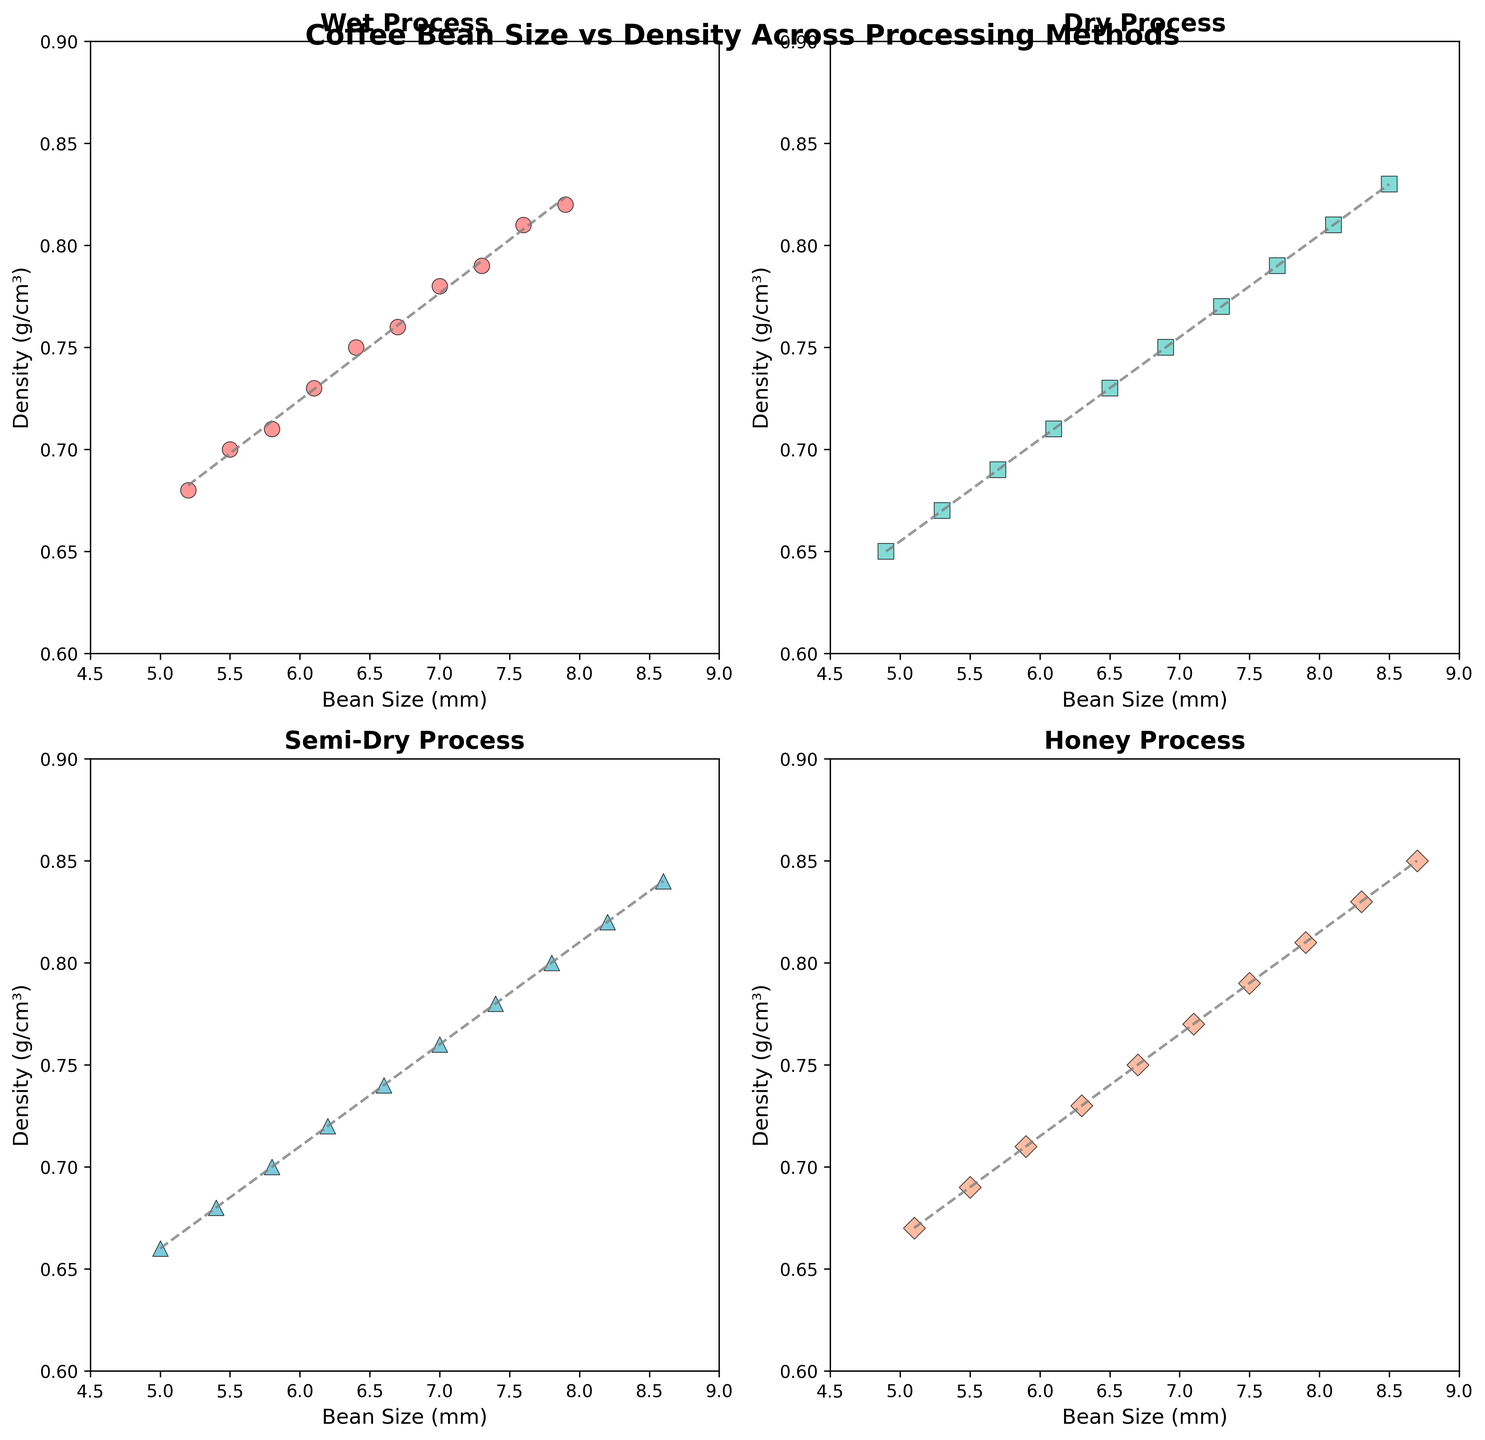What's the average bean size for the Dry Process? To find the average bean size for the Dry Process, add all the bean sizes for the Dry Process and divide by the number of data points: (4.9 + 5.3 + 5.7 + 6.1 + 6.5 + 6.9 + 7.3 + 7.7 + 8.1 + 8.5) / 10 = 6.7 mm.
Answer: 6.7 mm Which processing method shows the highest maximum density? Compare the maximum densities for each processing method: Wet Process (0.82), Dry Process (0.83), Semi-Dry Process (0.84), and Honey Process (0.85). The highest maximum density is for the Honey Process.
Answer: Honey Process In which processing method is the smallest average bean size observed? Calculate the average bean size for each method and compare: Wet Process (6.5 mm), Dry Process (6.7 mm), Semi-Dry Process (6.9 mm), Honey Process (6.9 mm). The Wet Process has the smallest average bean size.
Answer: Wet Process Is there a trendline with a positive slope in the Wet Process subplot? Check the trendline in the Wet Process subplot; if it generally increases from left to right, then the trendline has a positive slope. Observing the trendline, it indeed has a positive slope.
Answer: Yes Are the Semi-Dry Process beans more dense than the Dry Process beans on average? Calculate the average density for each method: Dry Process (0.73 g/cm³), Semi-Dry Process (0.75 g/cm³). Compare the averages, showing that Semi-Dry Process beans are denser.
Answer: Yes Which processing method has the widest range of bean sizes? Calculate the range (max - min) of bean sizes for each method: Wet Process (7.9 - 5.2 = 2.7), Dry Process (8.5 - 4.9 = 3.6), Semi-Dry Process (8.6 - 5.0 = 3.6), Honey Process (8.7 - 5.1 = 3.6). The widest range is shared by the Dry Process, Semi-Dry Process, and Honey Process.
Answer: Dry, Semi-Dry, Honey Does the trendline for the Honey Process subplot exhibit a steeper slope than the Semi-Dry Process subplot? Compare the slopes of the trendlines visually from the subplots. The Honey Process trendline appears to have a steeper slope than the Semi-Dry Process trendline.
Answer: Yes Are there any processing methods where all bean densities are less than 0.7 g/cm³? Check each subplot to see if any processing method consistently has densities below 0.7 g/cm³. No method shows all densities below 0.7 g/cm³.
Answer: No How does the average density of beans in the Wet Process compare to the density at the largest bean size for the Dry Process? Calculate the average density for the Wet Process (0.73 g/cm³), and compare it with the density at the largest bean size for the Dry Process (0.83 g/cm³). The density at the largest bean size for the Dry Process is greater.
Answer: The density at the largest bean size for Dry Process is greater Are there any overlapping density ranges between the Wet Process and Semi-Dry Process? Compare the density ranges for Wet Process (0.68 - 0.82) and Semi-Dry Process (0.66 - 0.84). The overlapping range is 0.68 to 0.82.
Answer: Yes 